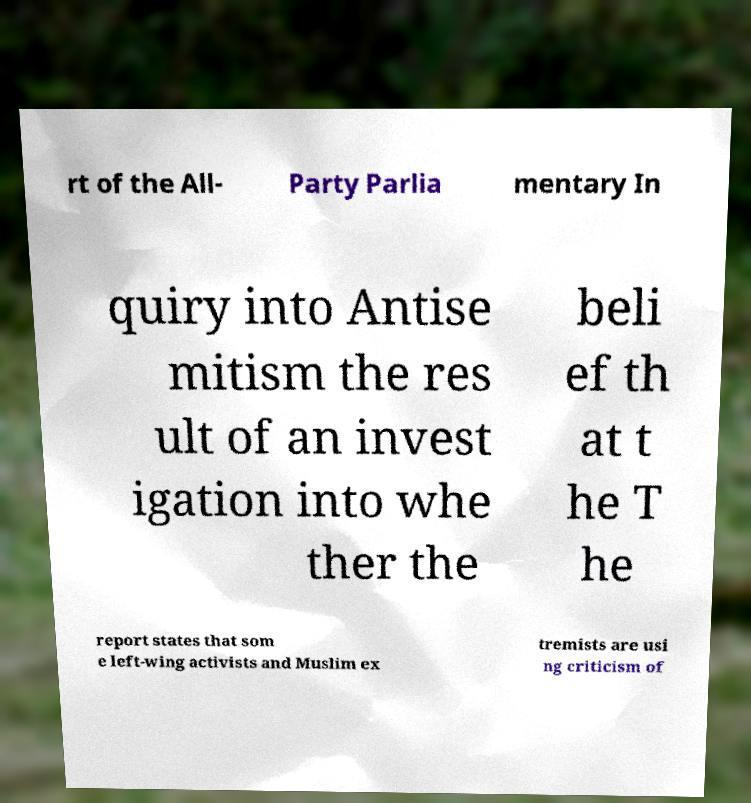There's text embedded in this image that I need extracted. Can you transcribe it verbatim? rt of the All- Party Parlia mentary In quiry into Antise mitism the res ult of an invest igation into whe ther the beli ef th at t he T he report states that som e left-wing activists and Muslim ex tremists are usi ng criticism of 